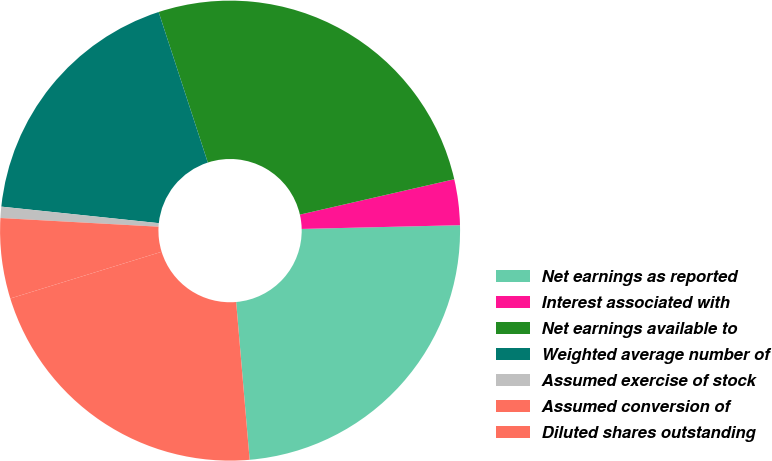<chart> <loc_0><loc_0><loc_500><loc_500><pie_chart><fcel>Net earnings as reported<fcel>Interest associated with<fcel>Net earnings available to<fcel>Weighted average number of<fcel>Assumed exercise of stock<fcel>Assumed conversion of<fcel>Diluted shares outstanding<nl><fcel>24.02%<fcel>3.21%<fcel>26.44%<fcel>18.31%<fcel>0.79%<fcel>5.64%<fcel>21.59%<nl></chart> 